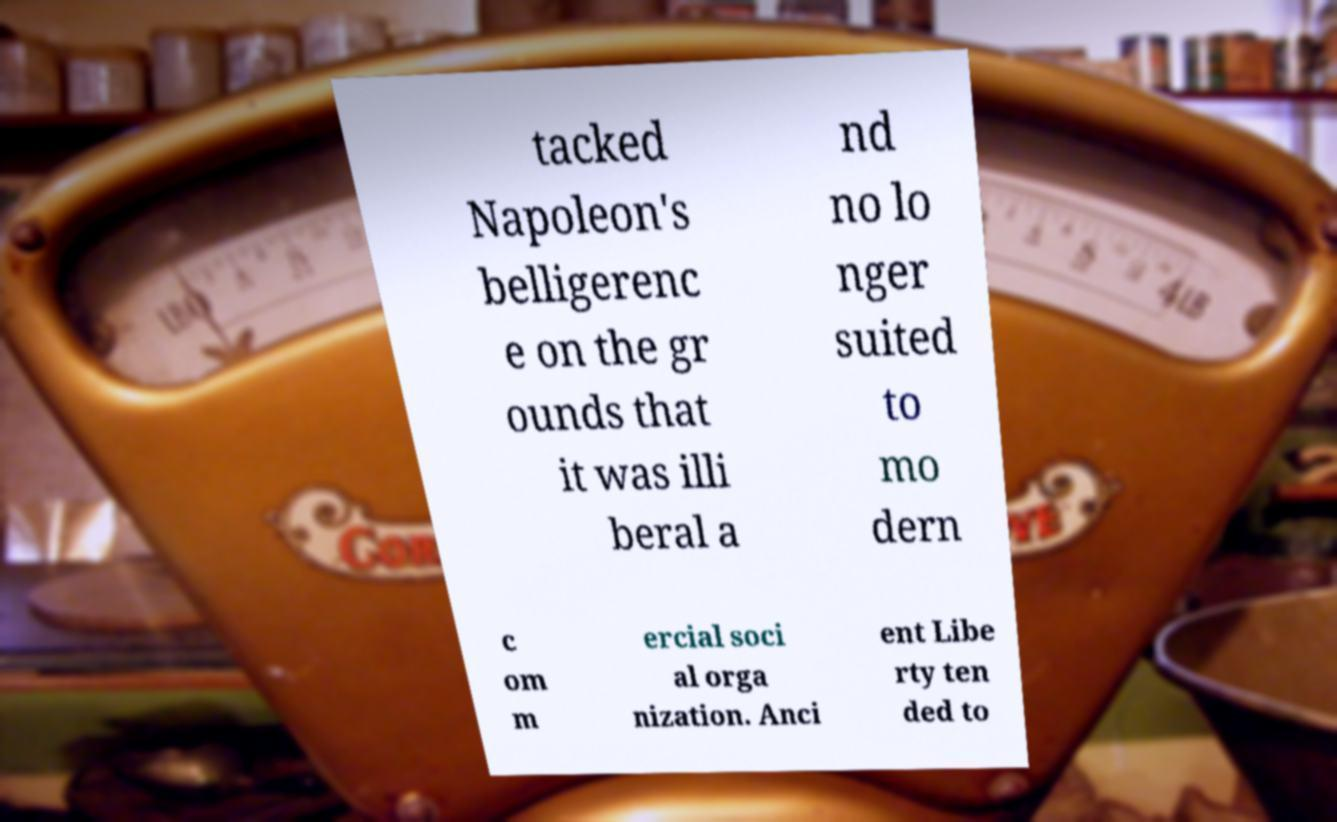Could you extract and type out the text from this image? tacked Napoleon's belligerenc e on the gr ounds that it was illi beral a nd no lo nger suited to mo dern c om m ercial soci al orga nization. Anci ent Libe rty ten ded to 